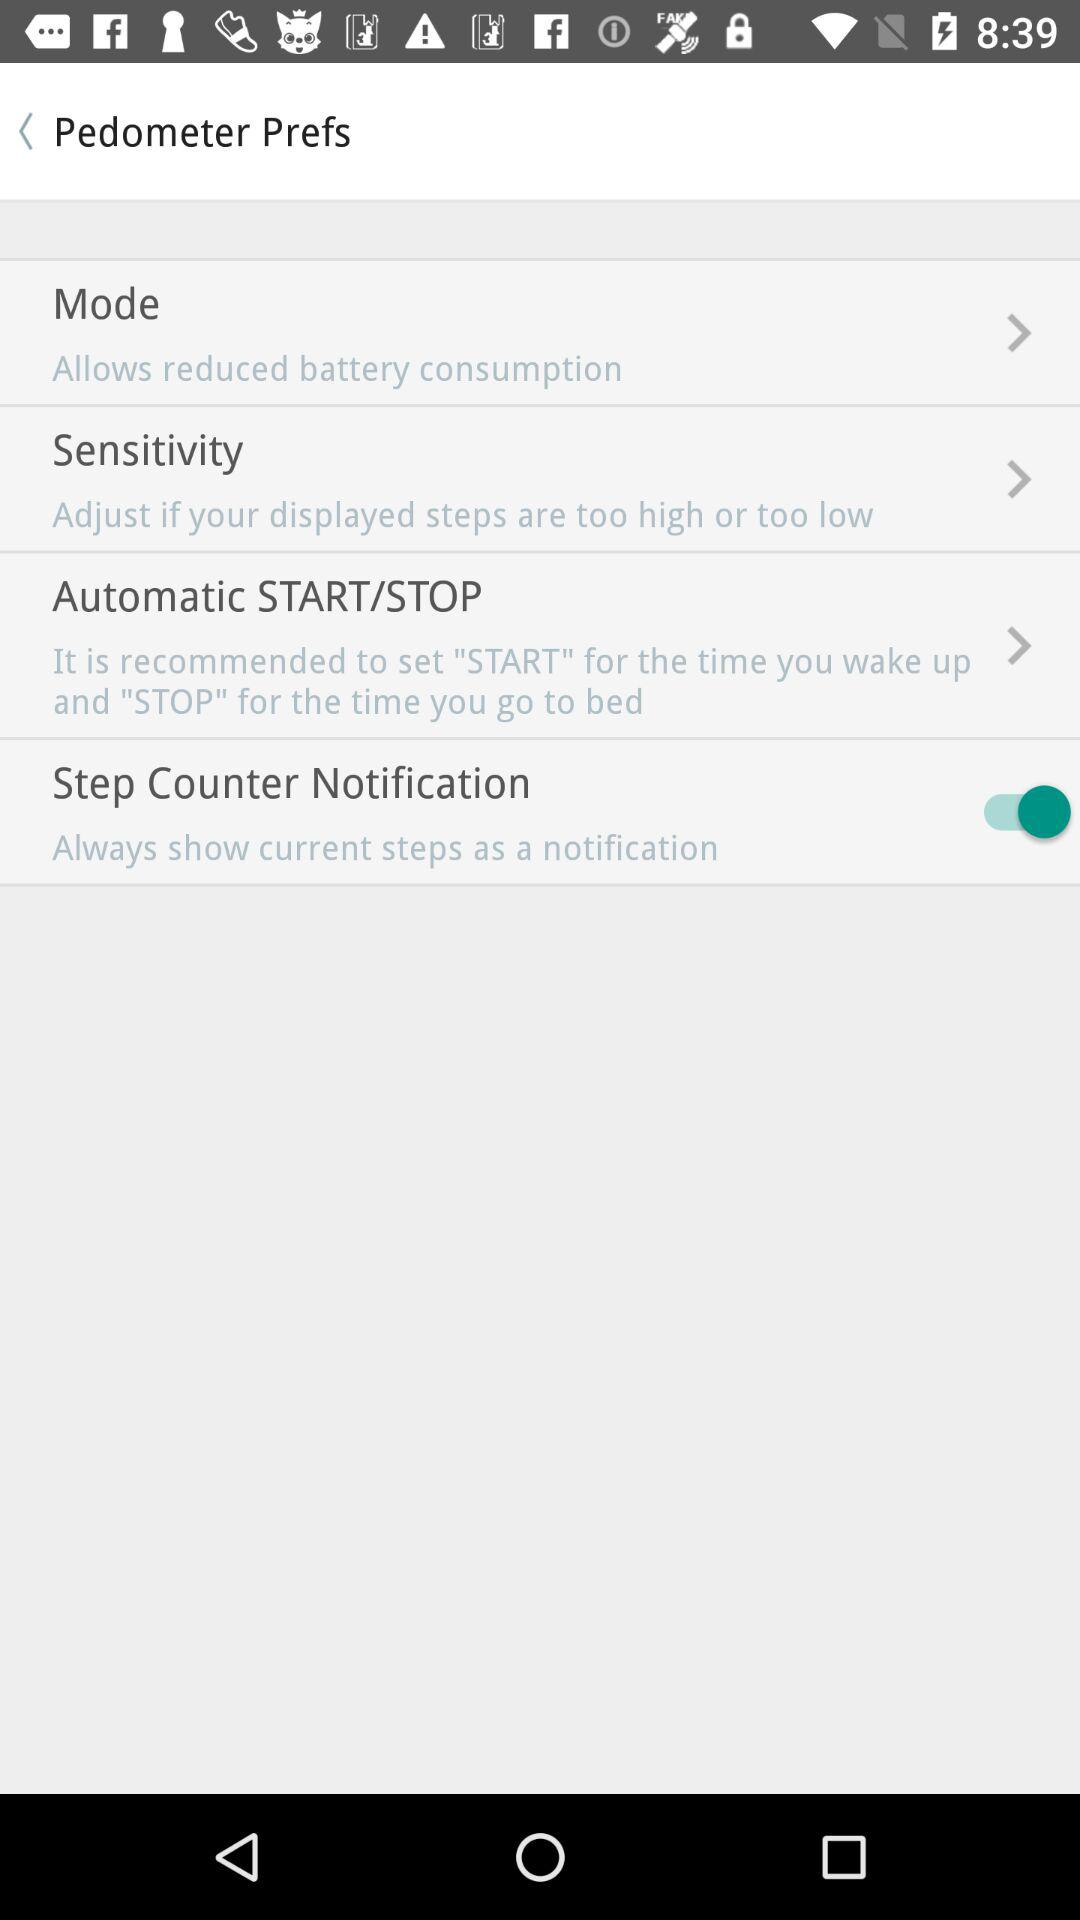What is the description of "Sensitivity"? The description of "Sensitivity" is "Adjust if your displayed steps are too high or too low". 